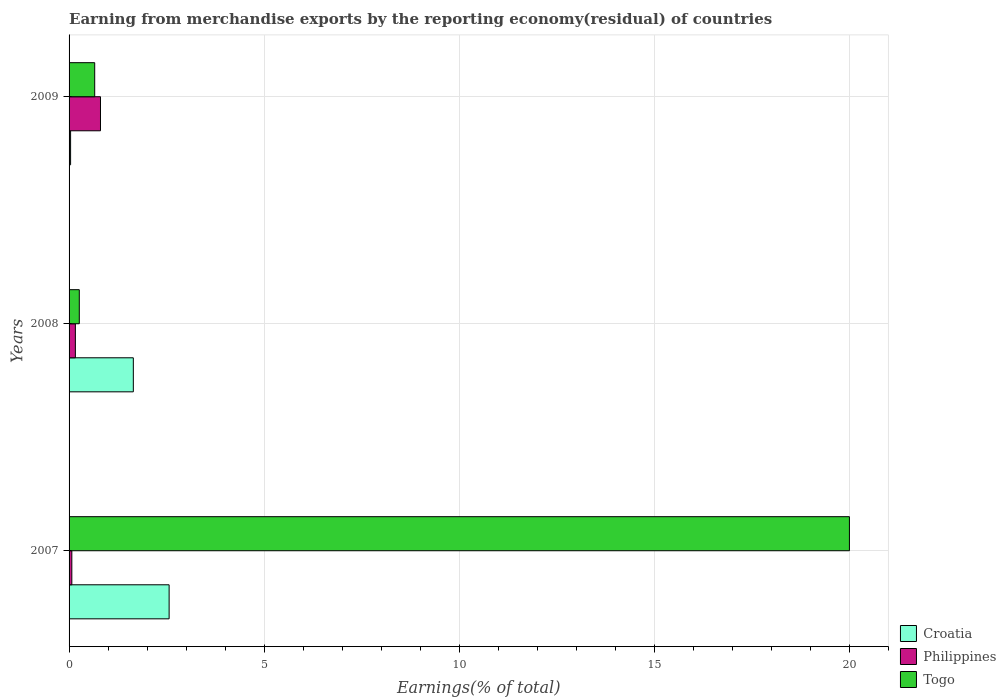How many different coloured bars are there?
Your answer should be compact. 3. How many groups of bars are there?
Offer a very short reply. 3. Are the number of bars per tick equal to the number of legend labels?
Give a very brief answer. Yes. How many bars are there on the 1st tick from the bottom?
Make the answer very short. 3. What is the label of the 1st group of bars from the top?
Keep it short and to the point. 2009. What is the percentage of amount earned from merchandise exports in Togo in 2007?
Your answer should be very brief. 20.01. Across all years, what is the maximum percentage of amount earned from merchandise exports in Philippines?
Give a very brief answer. 0.81. Across all years, what is the minimum percentage of amount earned from merchandise exports in Philippines?
Your response must be concise. 0.07. What is the total percentage of amount earned from merchandise exports in Togo in the graph?
Give a very brief answer. 20.93. What is the difference between the percentage of amount earned from merchandise exports in Philippines in 2007 and that in 2008?
Your answer should be compact. -0.09. What is the difference between the percentage of amount earned from merchandise exports in Philippines in 2009 and the percentage of amount earned from merchandise exports in Togo in 2007?
Your response must be concise. -19.2. What is the average percentage of amount earned from merchandise exports in Philippines per year?
Your response must be concise. 0.35. In the year 2007, what is the difference between the percentage of amount earned from merchandise exports in Togo and percentage of amount earned from merchandise exports in Croatia?
Offer a very short reply. 17.44. What is the ratio of the percentage of amount earned from merchandise exports in Croatia in 2007 to that in 2009?
Give a very brief answer. 66. Is the difference between the percentage of amount earned from merchandise exports in Togo in 2007 and 2009 greater than the difference between the percentage of amount earned from merchandise exports in Croatia in 2007 and 2009?
Give a very brief answer. Yes. What is the difference between the highest and the second highest percentage of amount earned from merchandise exports in Croatia?
Your answer should be compact. 0.92. What is the difference between the highest and the lowest percentage of amount earned from merchandise exports in Croatia?
Keep it short and to the point. 2.53. Is the sum of the percentage of amount earned from merchandise exports in Philippines in 2007 and 2008 greater than the maximum percentage of amount earned from merchandise exports in Togo across all years?
Provide a short and direct response. No. What does the 1st bar from the top in 2009 represents?
Make the answer very short. Togo. What does the 1st bar from the bottom in 2008 represents?
Offer a terse response. Croatia. Is it the case that in every year, the sum of the percentage of amount earned from merchandise exports in Togo and percentage of amount earned from merchandise exports in Philippines is greater than the percentage of amount earned from merchandise exports in Croatia?
Keep it short and to the point. No. Are all the bars in the graph horizontal?
Your answer should be compact. Yes. How many years are there in the graph?
Your response must be concise. 3. What is the difference between two consecutive major ticks on the X-axis?
Offer a terse response. 5. Does the graph contain any zero values?
Give a very brief answer. No. Where does the legend appear in the graph?
Give a very brief answer. Bottom right. How many legend labels are there?
Your answer should be very brief. 3. What is the title of the graph?
Offer a terse response. Earning from merchandise exports by the reporting economy(residual) of countries. Does "Swaziland" appear as one of the legend labels in the graph?
Ensure brevity in your answer.  No. What is the label or title of the X-axis?
Your answer should be compact. Earnings(% of total). What is the Earnings(% of total) of Croatia in 2007?
Offer a very short reply. 2.57. What is the Earnings(% of total) of Philippines in 2007?
Your answer should be compact. 0.07. What is the Earnings(% of total) in Togo in 2007?
Your answer should be very brief. 20.01. What is the Earnings(% of total) in Croatia in 2008?
Your answer should be compact. 1.65. What is the Earnings(% of total) in Philippines in 2008?
Keep it short and to the point. 0.16. What is the Earnings(% of total) of Togo in 2008?
Give a very brief answer. 0.26. What is the Earnings(% of total) of Croatia in 2009?
Keep it short and to the point. 0.04. What is the Earnings(% of total) in Philippines in 2009?
Offer a very short reply. 0.81. What is the Earnings(% of total) of Togo in 2009?
Give a very brief answer. 0.66. Across all years, what is the maximum Earnings(% of total) in Croatia?
Your answer should be very brief. 2.57. Across all years, what is the maximum Earnings(% of total) in Philippines?
Your answer should be very brief. 0.81. Across all years, what is the maximum Earnings(% of total) of Togo?
Keep it short and to the point. 20.01. Across all years, what is the minimum Earnings(% of total) of Croatia?
Your response must be concise. 0.04. Across all years, what is the minimum Earnings(% of total) of Philippines?
Your response must be concise. 0.07. Across all years, what is the minimum Earnings(% of total) in Togo?
Provide a succinct answer. 0.26. What is the total Earnings(% of total) in Croatia in the graph?
Your answer should be very brief. 4.25. What is the total Earnings(% of total) of Philippines in the graph?
Provide a short and direct response. 1.04. What is the total Earnings(% of total) in Togo in the graph?
Offer a very short reply. 20.93. What is the difference between the Earnings(% of total) of Croatia in 2007 and that in 2008?
Offer a very short reply. 0.92. What is the difference between the Earnings(% of total) of Philippines in 2007 and that in 2008?
Your answer should be very brief. -0.09. What is the difference between the Earnings(% of total) in Togo in 2007 and that in 2008?
Keep it short and to the point. 19.75. What is the difference between the Earnings(% of total) in Croatia in 2007 and that in 2009?
Offer a terse response. 2.53. What is the difference between the Earnings(% of total) of Philippines in 2007 and that in 2009?
Give a very brief answer. -0.73. What is the difference between the Earnings(% of total) in Togo in 2007 and that in 2009?
Keep it short and to the point. 19.35. What is the difference between the Earnings(% of total) in Croatia in 2008 and that in 2009?
Your answer should be compact. 1.61. What is the difference between the Earnings(% of total) in Philippines in 2008 and that in 2009?
Give a very brief answer. -0.64. What is the difference between the Earnings(% of total) in Togo in 2008 and that in 2009?
Offer a very short reply. -0.4. What is the difference between the Earnings(% of total) in Croatia in 2007 and the Earnings(% of total) in Philippines in 2008?
Your answer should be compact. 2.4. What is the difference between the Earnings(% of total) of Croatia in 2007 and the Earnings(% of total) of Togo in 2008?
Give a very brief answer. 2.3. What is the difference between the Earnings(% of total) in Philippines in 2007 and the Earnings(% of total) in Togo in 2008?
Your answer should be compact. -0.19. What is the difference between the Earnings(% of total) in Croatia in 2007 and the Earnings(% of total) in Philippines in 2009?
Offer a very short reply. 1.76. What is the difference between the Earnings(% of total) in Croatia in 2007 and the Earnings(% of total) in Togo in 2009?
Offer a very short reply. 1.91. What is the difference between the Earnings(% of total) of Philippines in 2007 and the Earnings(% of total) of Togo in 2009?
Give a very brief answer. -0.59. What is the difference between the Earnings(% of total) of Croatia in 2008 and the Earnings(% of total) of Philippines in 2009?
Offer a terse response. 0.84. What is the difference between the Earnings(% of total) in Croatia in 2008 and the Earnings(% of total) in Togo in 2009?
Your response must be concise. 0.99. What is the difference between the Earnings(% of total) of Philippines in 2008 and the Earnings(% of total) of Togo in 2009?
Offer a terse response. -0.5. What is the average Earnings(% of total) of Croatia per year?
Offer a very short reply. 1.42. What is the average Earnings(% of total) of Philippines per year?
Your response must be concise. 0.35. What is the average Earnings(% of total) of Togo per year?
Make the answer very short. 6.98. In the year 2007, what is the difference between the Earnings(% of total) of Croatia and Earnings(% of total) of Philippines?
Provide a short and direct response. 2.49. In the year 2007, what is the difference between the Earnings(% of total) in Croatia and Earnings(% of total) in Togo?
Your answer should be compact. -17.44. In the year 2007, what is the difference between the Earnings(% of total) in Philippines and Earnings(% of total) in Togo?
Provide a succinct answer. -19.94. In the year 2008, what is the difference between the Earnings(% of total) of Croatia and Earnings(% of total) of Philippines?
Your answer should be very brief. 1.49. In the year 2008, what is the difference between the Earnings(% of total) in Croatia and Earnings(% of total) in Togo?
Your response must be concise. 1.39. In the year 2008, what is the difference between the Earnings(% of total) of Philippines and Earnings(% of total) of Togo?
Ensure brevity in your answer.  -0.1. In the year 2009, what is the difference between the Earnings(% of total) of Croatia and Earnings(% of total) of Philippines?
Give a very brief answer. -0.77. In the year 2009, what is the difference between the Earnings(% of total) in Croatia and Earnings(% of total) in Togo?
Offer a terse response. -0.62. In the year 2009, what is the difference between the Earnings(% of total) of Philippines and Earnings(% of total) of Togo?
Ensure brevity in your answer.  0.15. What is the ratio of the Earnings(% of total) in Croatia in 2007 to that in 2008?
Offer a terse response. 1.56. What is the ratio of the Earnings(% of total) of Philippines in 2007 to that in 2008?
Ensure brevity in your answer.  0.44. What is the ratio of the Earnings(% of total) of Togo in 2007 to that in 2008?
Your response must be concise. 76.35. What is the ratio of the Earnings(% of total) of Croatia in 2007 to that in 2009?
Ensure brevity in your answer.  66. What is the ratio of the Earnings(% of total) of Philippines in 2007 to that in 2009?
Give a very brief answer. 0.09. What is the ratio of the Earnings(% of total) of Togo in 2007 to that in 2009?
Ensure brevity in your answer.  30.45. What is the ratio of the Earnings(% of total) in Croatia in 2008 to that in 2009?
Keep it short and to the point. 42.39. What is the ratio of the Earnings(% of total) in Philippines in 2008 to that in 2009?
Your answer should be very brief. 0.2. What is the ratio of the Earnings(% of total) in Togo in 2008 to that in 2009?
Provide a short and direct response. 0.4. What is the difference between the highest and the second highest Earnings(% of total) of Croatia?
Your response must be concise. 0.92. What is the difference between the highest and the second highest Earnings(% of total) of Philippines?
Give a very brief answer. 0.64. What is the difference between the highest and the second highest Earnings(% of total) in Togo?
Your answer should be very brief. 19.35. What is the difference between the highest and the lowest Earnings(% of total) of Croatia?
Your answer should be compact. 2.53. What is the difference between the highest and the lowest Earnings(% of total) in Philippines?
Provide a succinct answer. 0.73. What is the difference between the highest and the lowest Earnings(% of total) in Togo?
Offer a very short reply. 19.75. 